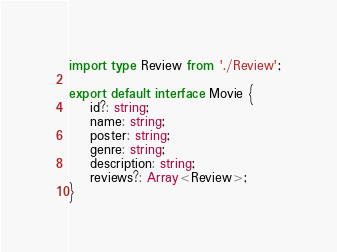<code> <loc_0><loc_0><loc_500><loc_500><_TypeScript_>import type Review from './Review';

export default interface Movie {
    id?: string;
    name: string;
    poster: string;
    genre: string;
    description: string;
    reviews?: Array<Review>;
}
</code> 